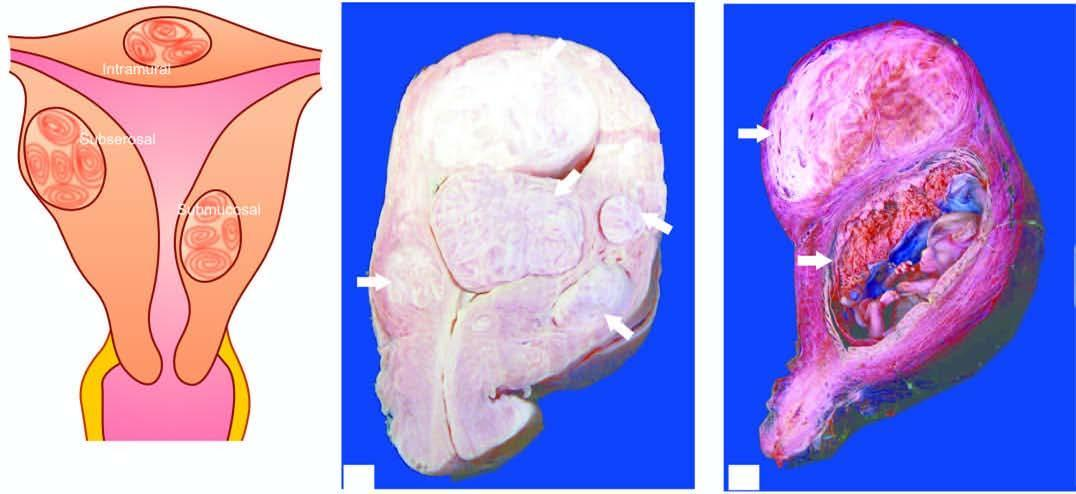what does sectioned surface of the uterus show?
Answer the question using a single word or phrase. Multiple circumscribed 